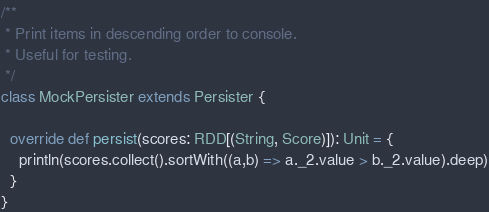<code> <loc_0><loc_0><loc_500><loc_500><_Scala_>
/**
 * Print items in descending order to console.
 * Useful for testing.
 */
class MockPersister extends Persister {

  override def persist(scores: RDD[(String, Score)]): Unit = {
    println(scores.collect().sortWith((a,b) => a._2.value > b._2.value).deep)
  }
}</code> 